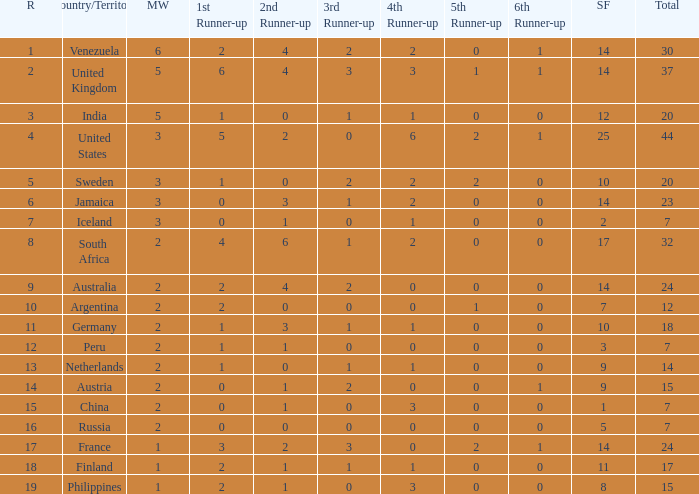What number does venezuela hold in the overall rank? 30.0. 